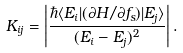<formula> <loc_0><loc_0><loc_500><loc_500>K _ { i j } = \left | \frac { \hbar { \langle } E _ { i } | ( \partial H / \partial f _ { s } ) | E _ { j } \rangle } { ( E _ { i } - E _ { j } ) ^ { 2 } } \right | .</formula> 